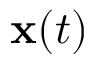Convert formula to latex. <formula><loc_0><loc_0><loc_500><loc_500>{ x } ( t )</formula> 